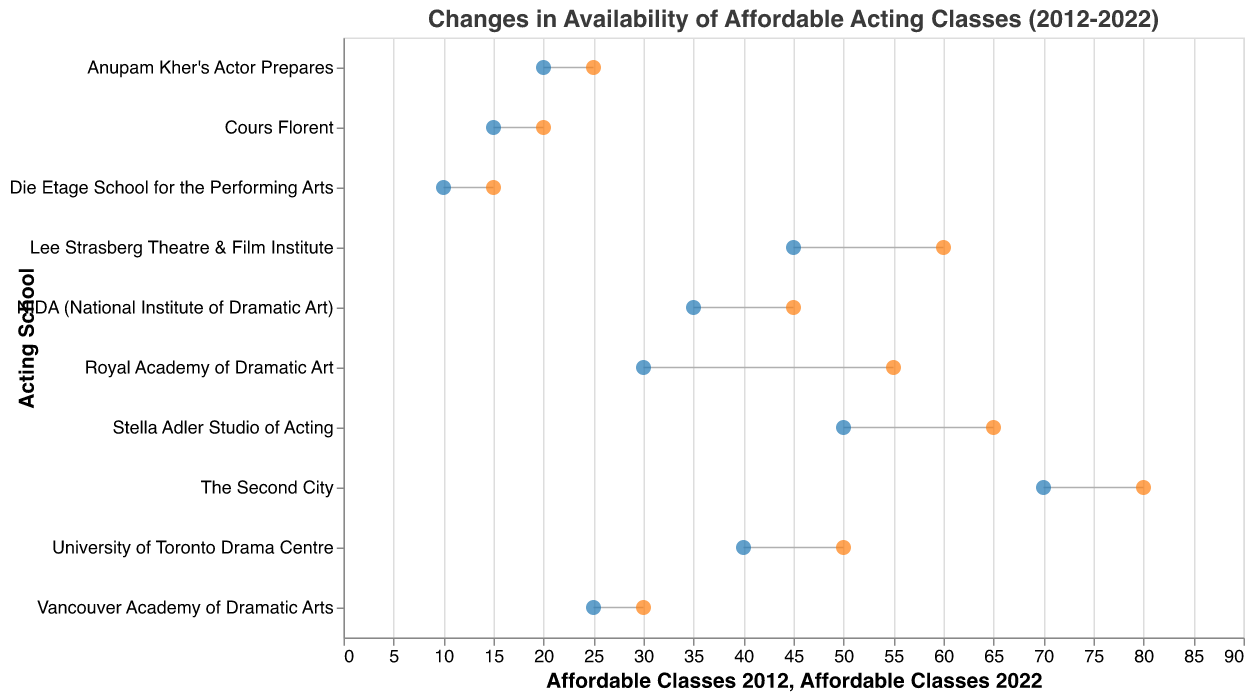How many acting schools are displayed in the figure? The figure lists data points for New York, Los Angeles, Chicago, London, Toronto, Sydney, Mumbai, Vancouver, Paris, and Berlin. Each city represents one acting school.
Answer: 10 Which acting school had the highest number of affordable classes in 2022? From the data points in the figure, "The Second City" in Chicago had 80 affordable classes in 2022, which is the highest among the listed acting schools.
Answer: The Second City What was the increase in the number of affordable classes for "Royal Academy of Dramatic Art" in London from 2012 to 2022? The data point for "Royal Academy of Dramatic Art" in London shows 30 affordable classes in 2012 and 55 in 2022. The increase is calculated as 55 - 30.
Answer: 25 Which city experienced the smallest increase in the number of affordable classes from 2012 to 2022? "Anupam Kher’s Actor Prepares" in Mumbai had 20 affordable classes in 2012 and 25 in 2022, making the increase 5 classes, which is the smallest among the listed acting schools.
Answer: Mumbai What is the average number of affordable classes across all acting schools in 2012? Summing the number of affordable classes for all acting schools in 2012 (50 + 45 + 70 + 30 + 40 + 35 + 20 + 25 + 15 + 10) gives 340. Dividing by the number of acting schools (10) results in 340 / 10.
Answer: 34 How many more affordable classes did "Stella Adler Studio of Acting" in New York offer in 2022 compared to "Die Etage School for the Performing Arts" in Berlin? "Stella Adler Studio of Acting" had 65 affordable classes in 2022, and "Die Etage School for the Performing Arts" had 15 in 2022. The difference is calculated as 65 - 15.
Answer: 50 Which acting school offered the same increase in affordable classes as "NIDA (National Institute of Dramatic Art)" in Sydney from 2012 to 2022? "NIDA (National Institute of Dramatic Art)" in Sydney increased by 10 classes (from 35 to 45). Both "Vancouver Academy of Dramatic Arts" in Vancouver (25 to 30) and "Cours Florent" in Paris (15 to 20) also had the same increase of 10 classes.
Answer: Vancouver Academy of Dramatic Arts and Cours Florent What is the total number of affordable classes offered by all acting schools in 2022? Summing the number of affordable classes for all acting schools in 2022 (65 + 60 + 80 + 55 + 50 + 45 + 25 + 30 + 20 + 15) gives a total.
Answer: 445 Which acting school had the largest increase in affordable classes from 2012 to 2022? Among the data points, "Royal Academy of Dramatic Art" in London had the largest increase, going from 30 in 2012 to 55 in 2022, which is an increase of 25 classes.
Answer: Royal Academy of Dramatic Art How does the change in affordable classes for "The Second City" in Chicago compare to that for "Lee Strasberg Theatre & Film Institute" in Los Angeles? "The Second City" in Chicago increased by 10 classes (from 70 to 80), and "Lee Strasberg Theatre & Film Institute" in Los Angeles increased by 15 classes (from 45 to 60). Hence, Los Angeles saw a larger increase by 5 classes.
Answer: Los Angeles had a larger increase by 5 classes 